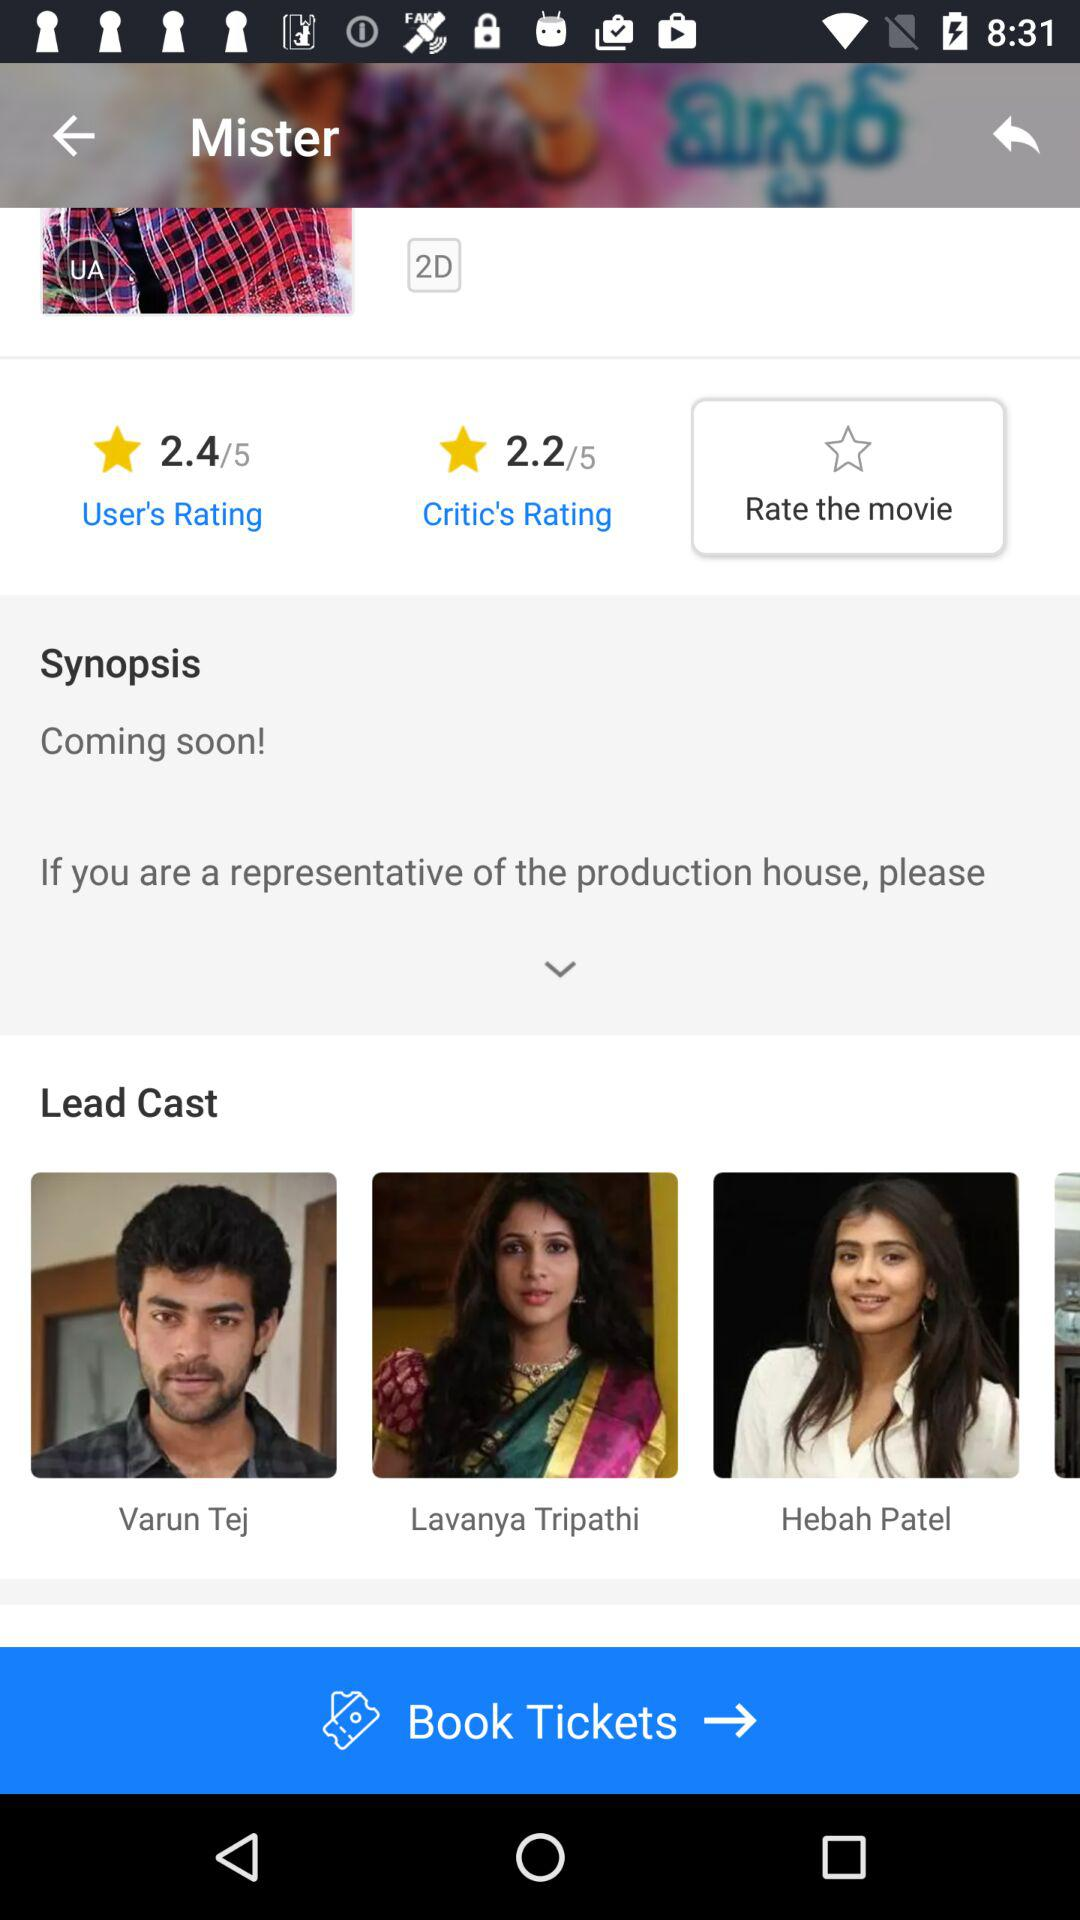What is the name of the movie? The name of the movie is "Mister". 